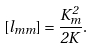Convert formula to latex. <formula><loc_0><loc_0><loc_500><loc_500>[ l _ { m m } ] = \frac { K _ { m } ^ { 2 } } { 2 K } .</formula> 